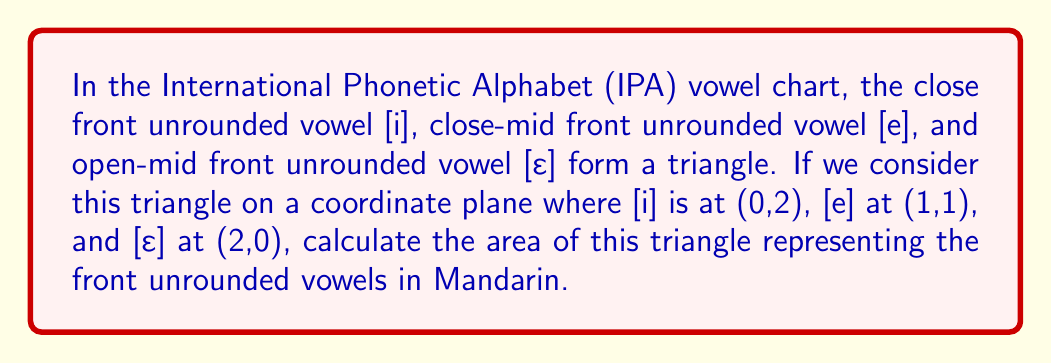Give your solution to this math problem. To calculate the area of the triangle formed by the vowel positions, we can use the formula for the area of a triangle given the coordinates of its vertices:

$$ A = \frac{1}{2}|x_1(y_2 - y_3) + x_2(y_3 - y_1) + x_3(y_1 - y_2)| $$

Where $(x_1, y_1)$, $(x_2, y_2)$, and $(x_3, y_3)$ are the coordinates of the three vertices.

Given:
- [i] at (0,2): $(x_1, y_1) = (0, 2)$
- [e] at (1,1): $(x_2, y_2) = (1, 1)$
- [ɛ] at (2,0): $(x_3, y_3) = (2, 0)$

Let's substitute these values into the formula:

$$ A = \frac{1}{2}|0(1 - 0) + 1(0 - 2) + 2(2 - 1)| $$

$$ A = \frac{1}{2}|0 + (-2) + 2| $$

$$ A = \frac{1}{2}|0| $$

$$ A = \frac{1}{2} \cdot 0 $$

$$ A = 0 $$

The area of the triangle is 0 square units. This result indicates that the three points are collinear, forming a straight line rather than a triangle. This linear arrangement reflects the gradual opening of the mouth from the close [i] to the open-mid [ɛ] in the front unrounded vowel series of Mandarin.
Answer: 0 square units 